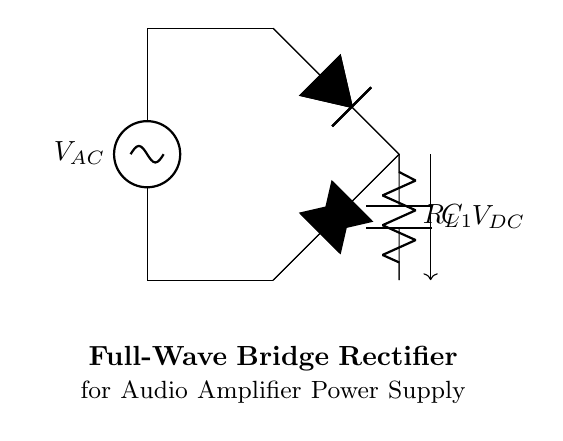What type of rectifier is shown? The circuit diagram depicts a full-wave bridge rectifier, which can be identified by the four diodes arranged in a bridge configuration. This configuration allows both halves of the AC input signal to be utilized to produce a DC output.
Answer: full-wave bridge rectifier What is the load resistor labeled as? In the circuit, the load resistor is identified by the symbol "R" with the label "R_L", indicating it is the load component connected to the output for drawing current from the rectifier.
Answer: R_L What is the role of capacitor C1 in the circuit? The capacitor C1 is used for filtering purposes. After rectification, the DC output can still have ripples; the capacitor smooths these ripples by charging and discharging, helping to maintain a steady DC voltage across the load.
Answer: filtering How many diodes are used in this rectifier? The circuit utilizes four diodes arranged in a bridge configuration. This is characteristic of a full-wave bridge rectifier, which employs these four diodes for efficient rectification of the AC input.
Answer: four What kind of current does the bridge rectifier output? The output of a full-wave bridge rectifier primarily produces direct current. This results from the full-wave rectification process that converts alternating current to a unidirectional flow.
Answer: direct current What does V_DC represent in the circuit? V_DC symbolizes the output voltage from the rectifier after the AC input has been converted to DC. It shows the voltage that is available across the load resistor after the rectification and smoothing process.
Answer: output voltage 